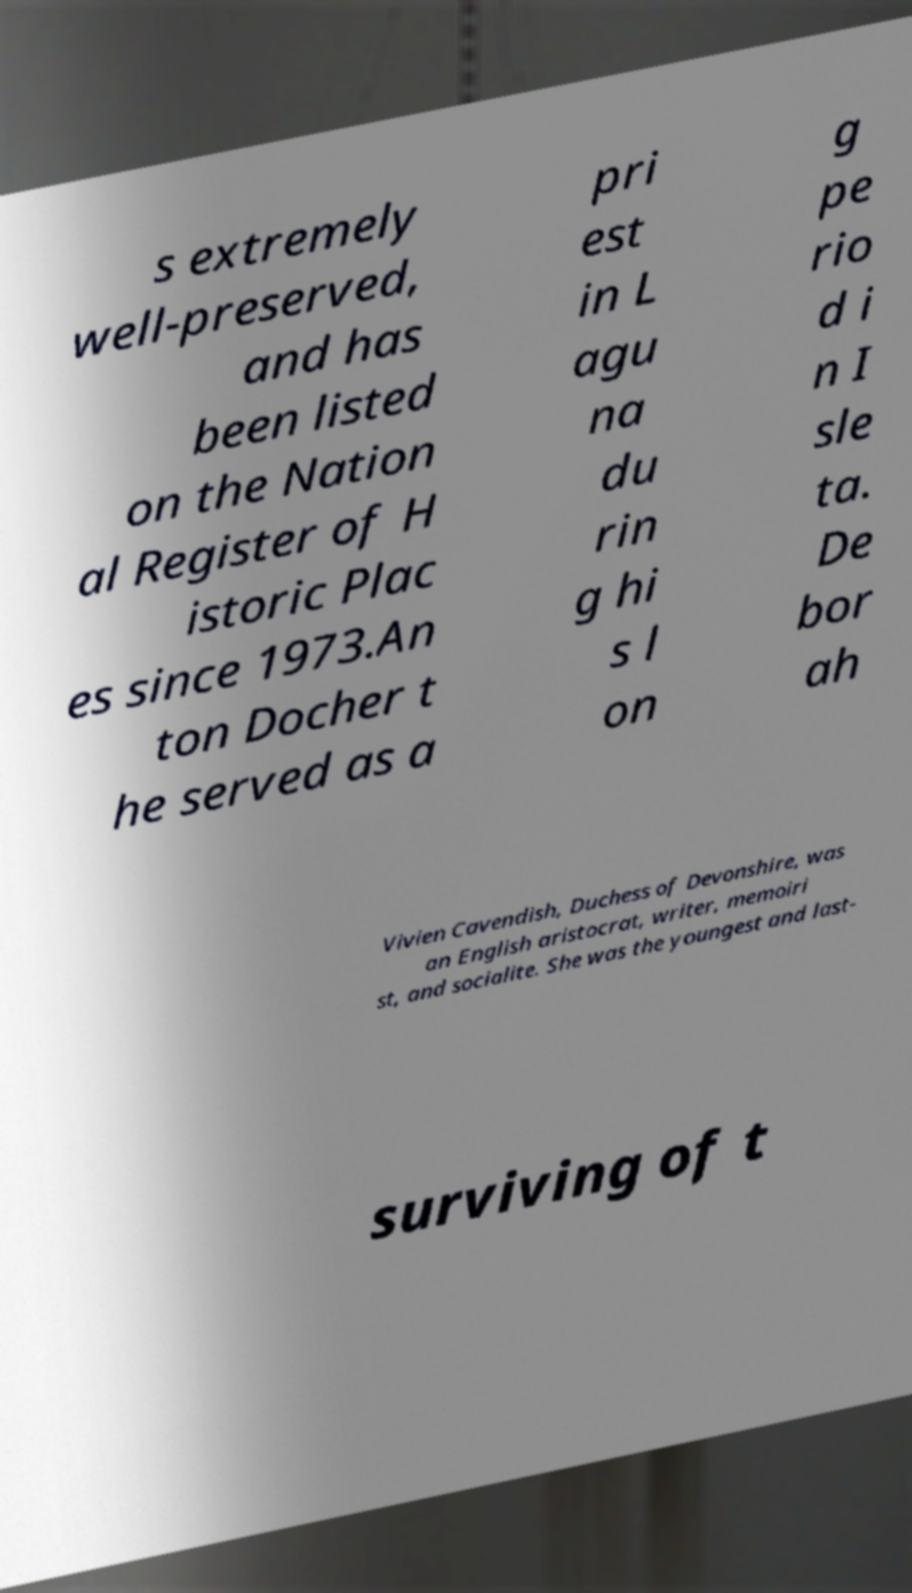There's text embedded in this image that I need extracted. Can you transcribe it verbatim? s extremely well-preserved, and has been listed on the Nation al Register of H istoric Plac es since 1973.An ton Docher t he served as a pri est in L agu na du rin g hi s l on g pe rio d i n I sle ta. De bor ah Vivien Cavendish, Duchess of Devonshire, was an English aristocrat, writer, memoiri st, and socialite. She was the youngest and last- surviving of t 